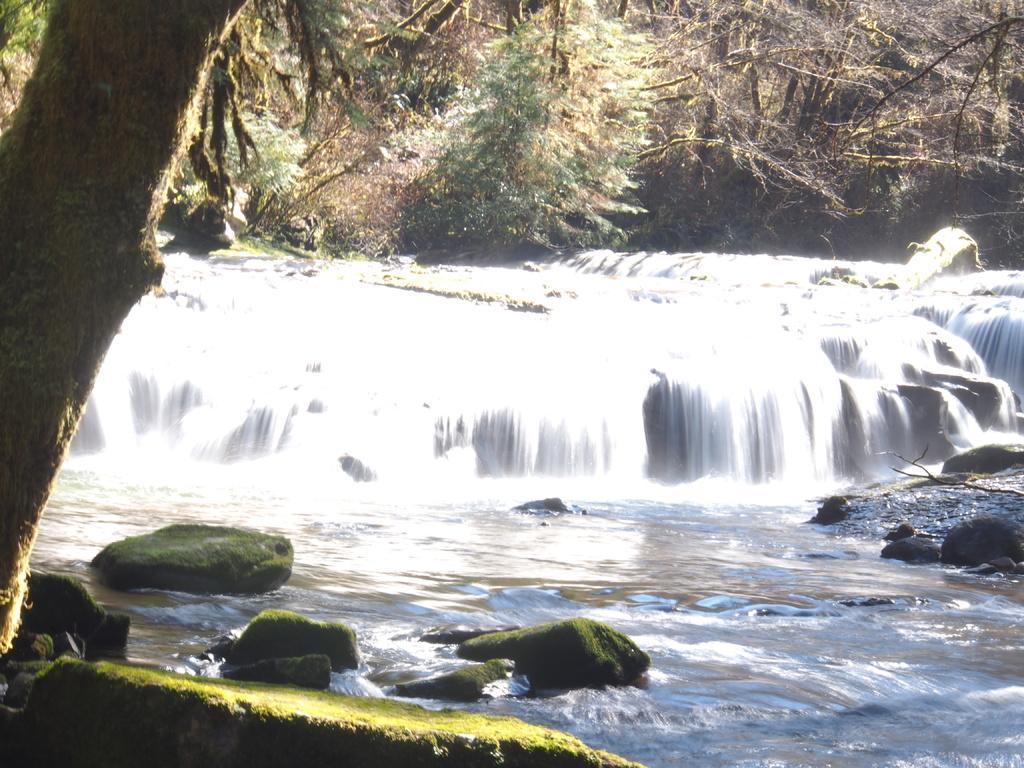Describe this image in one or two sentences. In this image, we can see trees, rocks and there are waterfalls. 